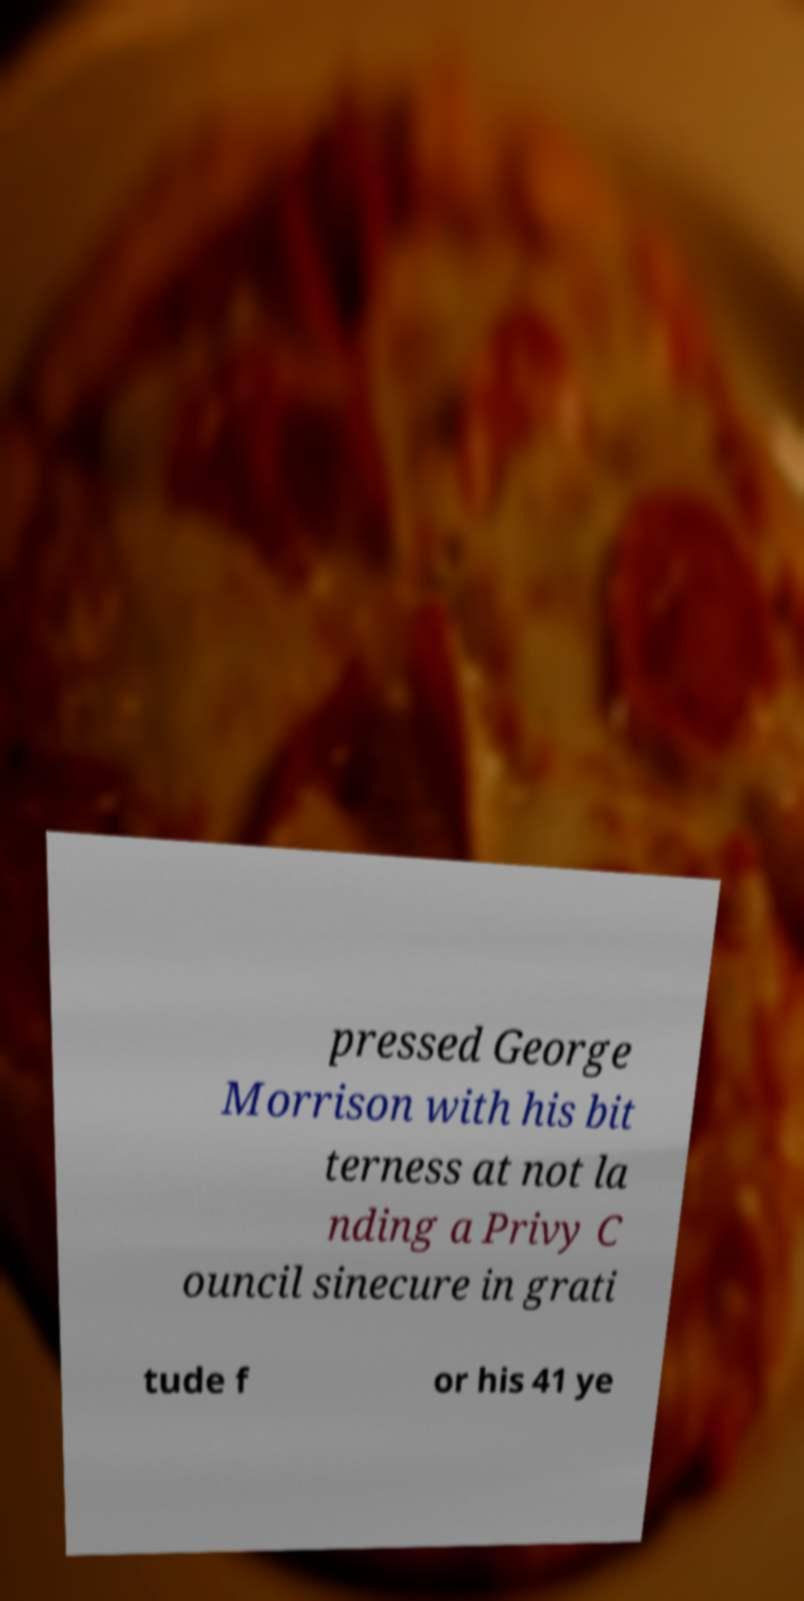Please identify and transcribe the text found in this image. pressed George Morrison with his bit terness at not la nding a Privy C ouncil sinecure in grati tude f or his 41 ye 